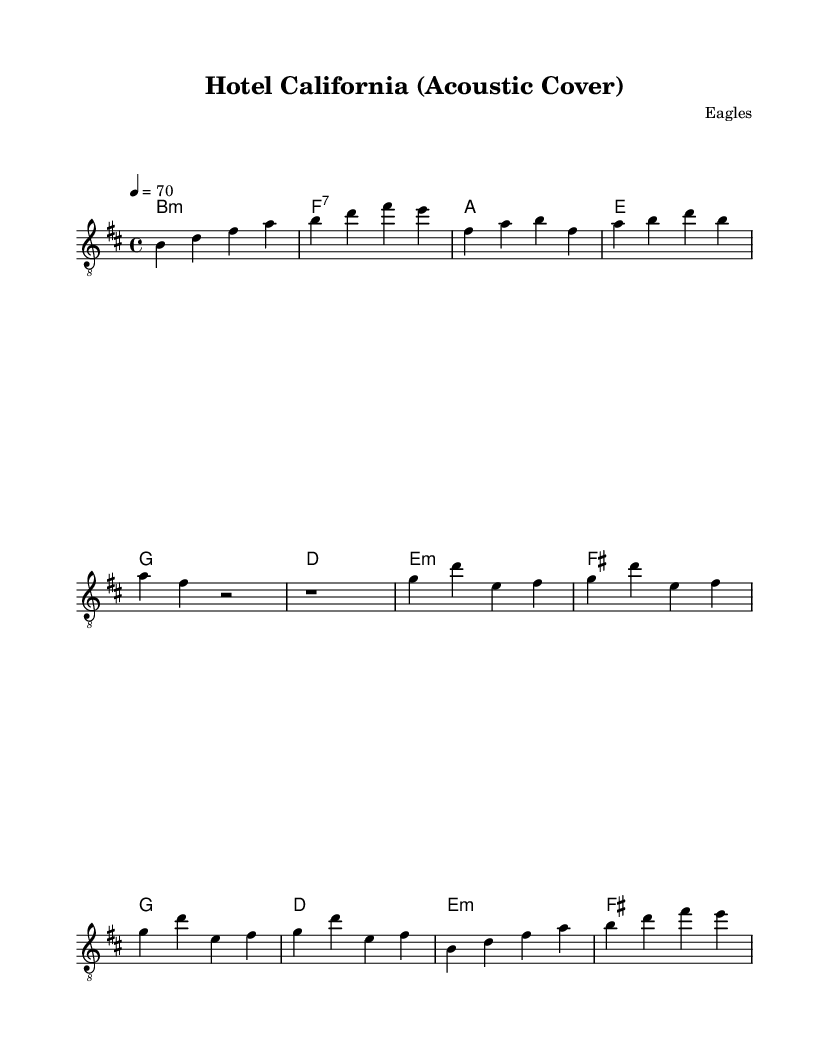What is the key signature of this music? The key signature for this piece is B minor, which contains two sharps (F# and C#). This is indicated in the header section at the beginning of the sheet music.
Answer: B minor What is the time signature of this music? The time signature is 4/4, which means there are four beats per measure, and the quarter note gets one beat. This is specified in the global section of the sheet music.
Answer: 4/4 What is the tempo marking for this piece? The tempo marking is 4 equals 70, indicating that each quarter note is to be played at a speed of 70 beats per minute. This is specified in the global section as well.
Answer: 70 How many measures are in the intro section? The intro contains 4 measures, as counted from the notation provided before the first verse starts. Each line has a specific number of notes, which adds up to 4 distinct measures.
Answer: 4 What type of chords are primarily used in this acoustic cover? The primary chords used in this piece are the minor and seventh chords, indicated by symbols like "b:m" for B minor and "f:7" for F7 throughout the chord progression.
Answer: Minor and seventh What is the first note played in the intro? The first note played in the intro is B, as noted in the guitar notes section, which sets the tonal center for the composition.
Answer: B What is the structure of the song based on this sheet music? The structure follows a typical format of Intro, Verse, Chorus, and Outro, clearly indicated by the separation of different sections within the music notation. This formula is common in popular songs for their flow.
Answer: Intro, Verse, Chorus, Outro 